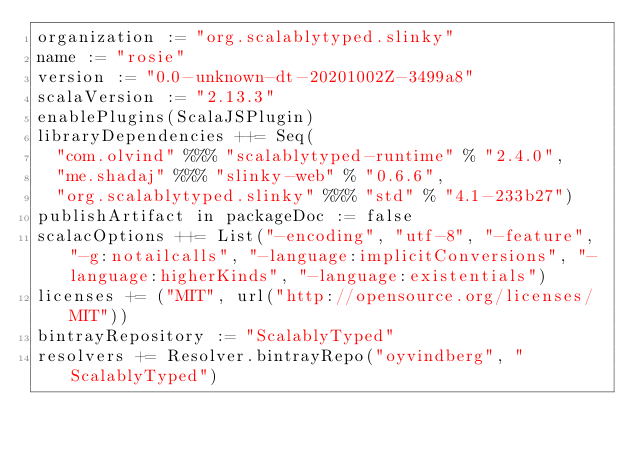<code> <loc_0><loc_0><loc_500><loc_500><_Scala_>organization := "org.scalablytyped.slinky"
name := "rosie"
version := "0.0-unknown-dt-20201002Z-3499a8"
scalaVersion := "2.13.3"
enablePlugins(ScalaJSPlugin)
libraryDependencies ++= Seq(
  "com.olvind" %%% "scalablytyped-runtime" % "2.4.0",
  "me.shadaj" %%% "slinky-web" % "0.6.6",
  "org.scalablytyped.slinky" %%% "std" % "4.1-233b27")
publishArtifact in packageDoc := false
scalacOptions ++= List("-encoding", "utf-8", "-feature", "-g:notailcalls", "-language:implicitConversions", "-language:higherKinds", "-language:existentials")
licenses += ("MIT", url("http://opensource.org/licenses/MIT"))
bintrayRepository := "ScalablyTyped"
resolvers += Resolver.bintrayRepo("oyvindberg", "ScalablyTyped")
</code> 